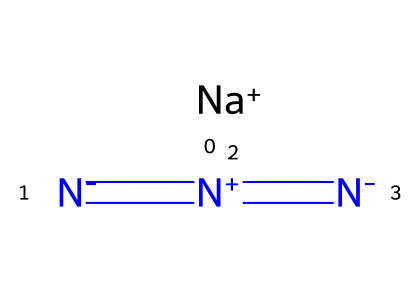What is the molecular formula of sodium azide? The SMILES shows the presence of sodium (Na) and three nitrogen atoms in a linear arrangement. Therefore, the molecular formula can be derived as NaN3.
Answer: NaN3 How many nitrogen atoms are in sodium azide? The SMILES indicates three nitrogen atoms connected through double bonds, indicated by the multiple '=' signs. Thus, sodium azide contains three nitrogen atoms.
Answer: 3 What type of compound is sodium azide? Based on the presence of the azide group (N3) adjacent to sodium (Na), sodium azide is classified as an inorganic azide.
Answer: inorganic azide What feature of sodium azide contributes to its reactivity? The presence of multiple nitrogen atoms with different charge states (indicated by [N-] and [N+] in the SMILES) denotes instability, contributing to its reactivity as azides generally undergo decomposition.
Answer: nitrogen connectivity What is the charge on sodium in sodium azide? The notation [Na+] indicates that sodium has a positive charge of +1, which is characteristic for alkali metals when forming ionic compounds.
Answer: +1 What type of bonding exists between the nitrogen atoms in sodium azide? The multiple '=' signs indicate double bonds between nitrogen atoms, showing that they are connected by covalent bonding.
Answer: covalent How does sodium azide act as a euthanasia agent? Sodium azide acts rapidly due to its ability to release nitrogen gas upon thermal decomposition, causing a quick effect, which is crucial for euthanasia.
Answer: rapid nitrogen release 